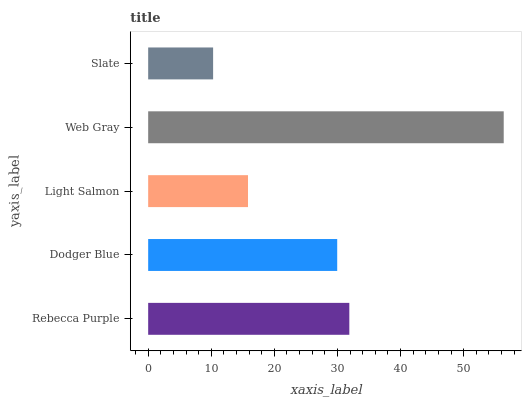Is Slate the minimum?
Answer yes or no. Yes. Is Web Gray the maximum?
Answer yes or no. Yes. Is Dodger Blue the minimum?
Answer yes or no. No. Is Dodger Blue the maximum?
Answer yes or no. No. Is Rebecca Purple greater than Dodger Blue?
Answer yes or no. Yes. Is Dodger Blue less than Rebecca Purple?
Answer yes or no. Yes. Is Dodger Blue greater than Rebecca Purple?
Answer yes or no. No. Is Rebecca Purple less than Dodger Blue?
Answer yes or no. No. Is Dodger Blue the high median?
Answer yes or no. Yes. Is Dodger Blue the low median?
Answer yes or no. Yes. Is Web Gray the high median?
Answer yes or no. No. Is Web Gray the low median?
Answer yes or no. No. 